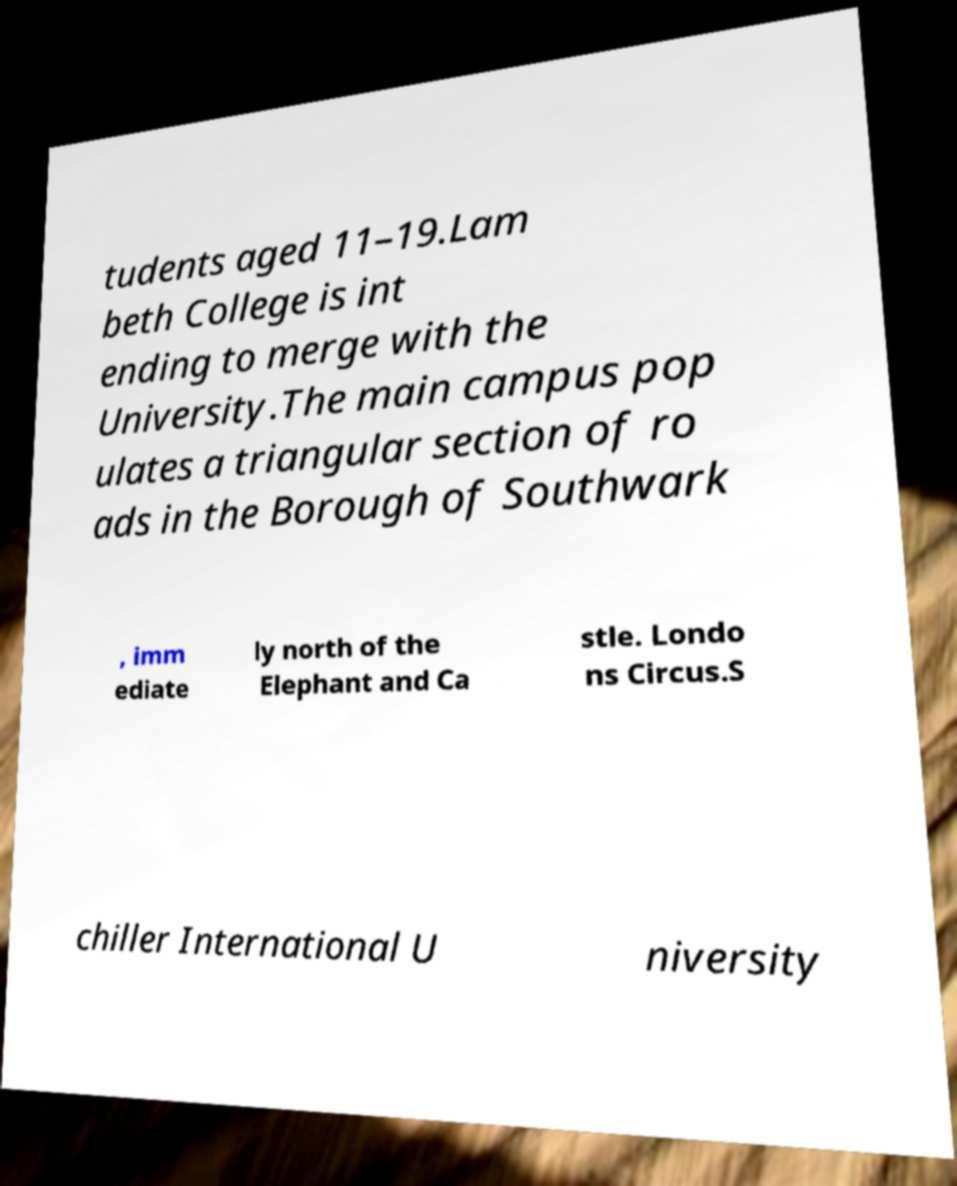Please read and relay the text visible in this image. What does it say? tudents aged 11–19.Lam beth College is int ending to merge with the University.The main campus pop ulates a triangular section of ro ads in the Borough of Southwark , imm ediate ly north of the Elephant and Ca stle. Londo ns Circus.S chiller International U niversity 